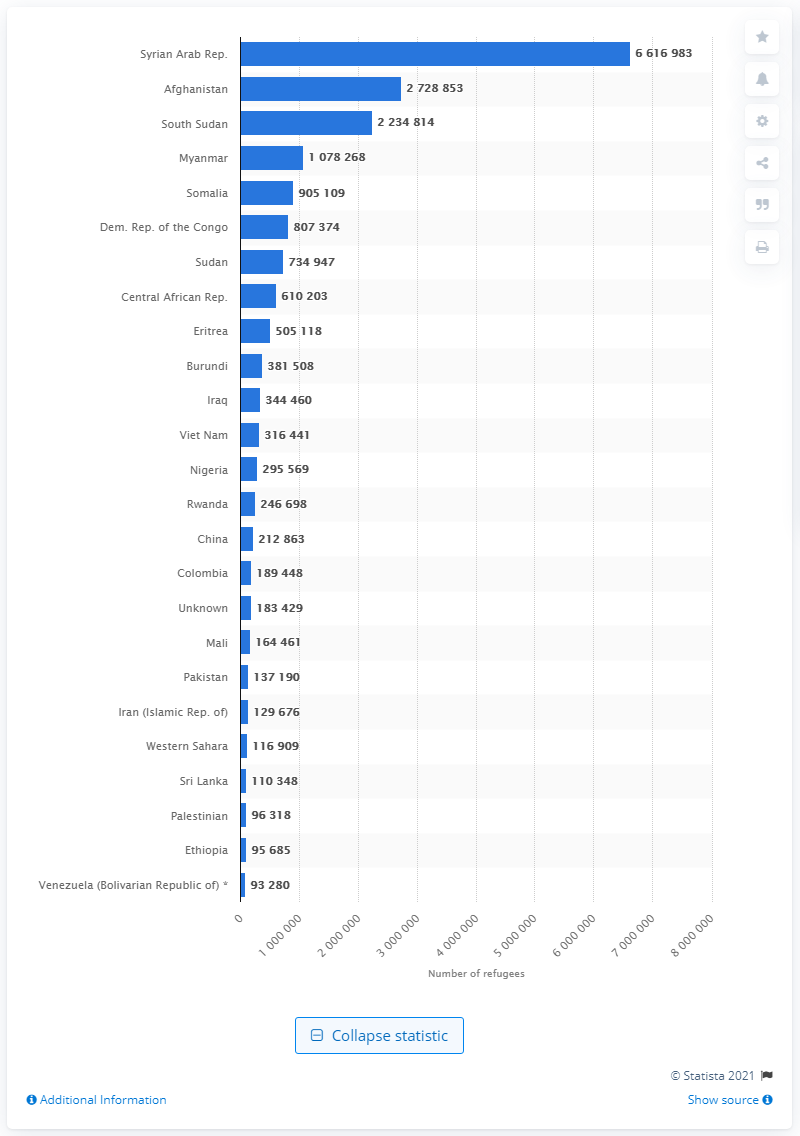List a handful of essential elements in this visual. In 2019, a significant number of refugees left the Syrian Arab Republic, with a total of 6616983 individuals departing. 